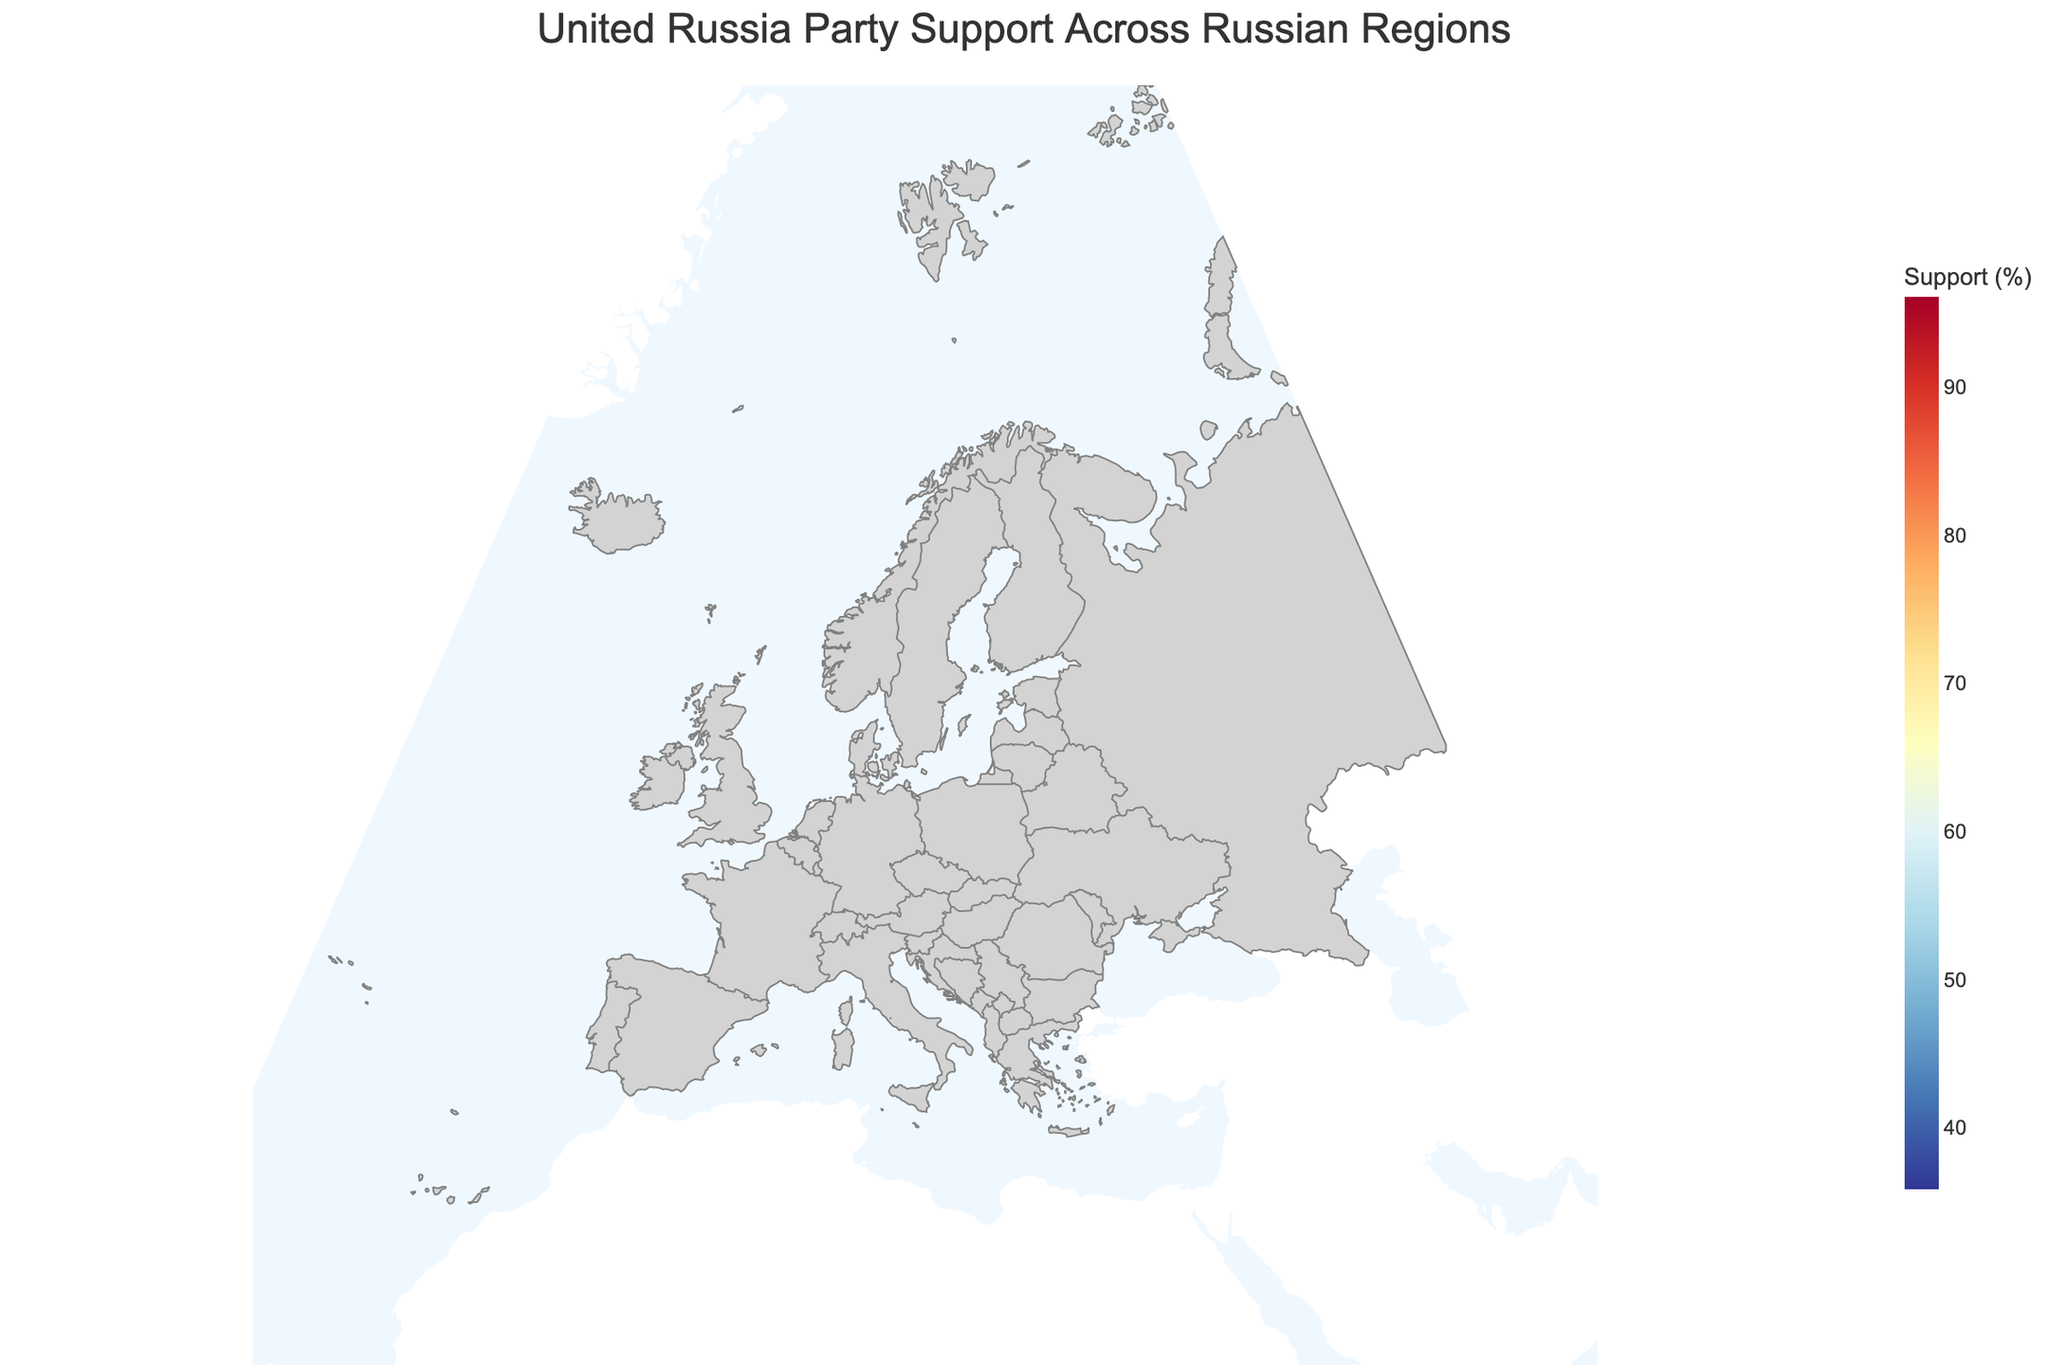What is the title of the plot? The title of the plot is usually at the top and describes the content or subject of the figure.
Answer: United Russia Party Support Across Russian Regions Which region has the highest support percentage for the United Russia party? The color scale on the geographic plot indicates support percentages, and the darkest hue representing the highest percentage is mapped to Chechnya.
Answer: Chechnya How does the support percentage in Dagestan compare to that in Moscow? By examining the map, Dagestan and Moscow show different hues corresponding to their support levels. Dagestan's hue represents a higher support percentage compared to Moscow.
Answer: Dagestan has higher support than Moscow What are the support percentages of the United Russia party in all specified regions? Each region on the map is shaded according to its specific support percentage. By hovering over or reading the legend, the specific percentages for all displayed regions can be determined.
Answer: Ranges from 35.9% to 96.1% Which regions have support percentages above 70%? Identify regions shaded with colors corresponding to over 70% support level on the color scale. These regions will have the highest intensity of the matching shading.
Answer: Tatarstan, Chechnya, Dagestan, Sevastopol What is the average support percentage across the listed regions? Sum the support percentages for all regions and divide by the number of regions: (62.3 + 54.7 + 78.9 + 96.1 + 38.2 + 41.5 + 68.7 + 46.9 + 89.2 + 53.1 + 44.8 + 58.6 + 74.2 + 39.7 + 35.9)/15
Answer: 58.1 How many regions show support percentages less than or equal to 50%? Count the regions marked by colors representing 50% or below according to the color scale.
Answer: 4 What is the range of support percentages in the figure? The range can be obtained by finding the difference between the highest and lowest support percentages displayed on the plot. Maximum is 96.1% and minimum is 35.9%.
Answer: 60.2 Which region has the lowest support percentage, and what is the value? Investigate the region indicated with the lightest hue which aligns with the lowest percentage on the color scale.
Answer: Khabarovsk Krai, 35.9% What is the support percentage in Primorsky Krai, and how does it compare to that in Krasnoyarsk Krai? Both regions need to be identified on the map and their support percentages compared; Primorsky Krai is 46.9% and Krasnoyarsk Krai is 53.1%.
Answer: Primorsky Krai is lower 